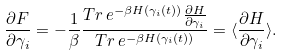Convert formula to latex. <formula><loc_0><loc_0><loc_500><loc_500>\frac { \partial { F } } { \partial { \gamma _ { i } } } = - \frac { 1 } { \beta } \frac { T r \, e ^ { - \beta { H ( \gamma _ { i } ( t ) ) } } \frac { \partial { H } } { \partial { \gamma _ { i } } } } { T r \, e ^ { - \beta { H ( \gamma _ { i } ( t ) ) } } } = \langle \frac { \partial { H } } { \partial { \gamma _ { i } } } \rangle .</formula> 